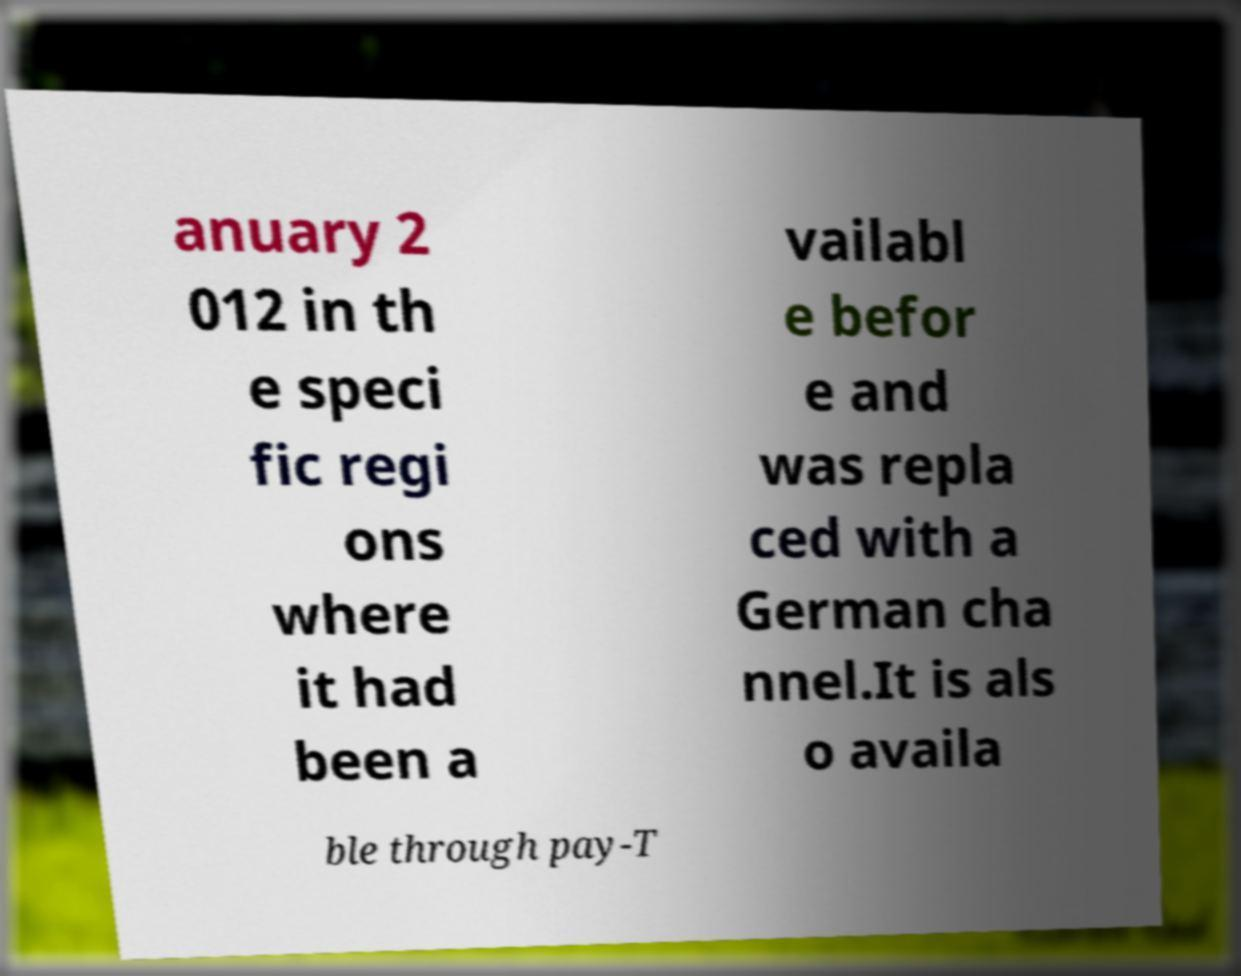What messages or text are displayed in this image? I need them in a readable, typed format. anuary 2 012 in th e speci fic regi ons where it had been a vailabl e befor e and was repla ced with a German cha nnel.It is als o availa ble through pay-T 